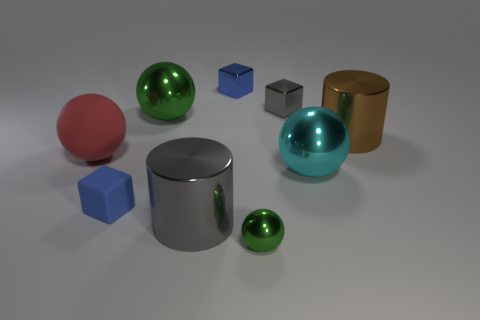Subtract all tiny gray metal blocks. How many blocks are left? 2 Add 1 big gray cylinders. How many objects exist? 10 Subtract all cyan balls. How many balls are left? 3 Subtract all blocks. How many objects are left? 6 Subtract 0 green cylinders. How many objects are left? 9 Subtract 2 balls. How many balls are left? 2 Subtract all blue balls. Subtract all brown cylinders. How many balls are left? 4 Subtract all yellow balls. How many gray cylinders are left? 1 Subtract all small metal cubes. Subtract all green objects. How many objects are left? 5 Add 3 large green balls. How many large green balls are left? 4 